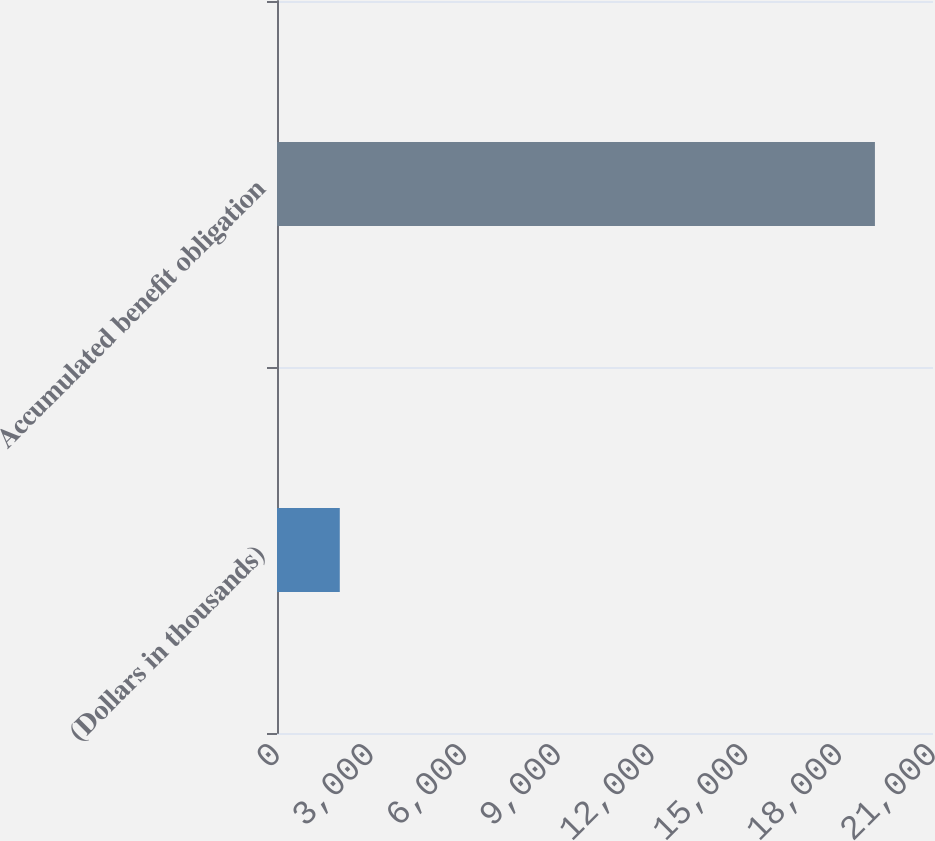Convert chart. <chart><loc_0><loc_0><loc_500><loc_500><bar_chart><fcel>(Dollars in thousands)<fcel>Accumulated benefit obligation<nl><fcel>2010<fcel>19141<nl></chart> 